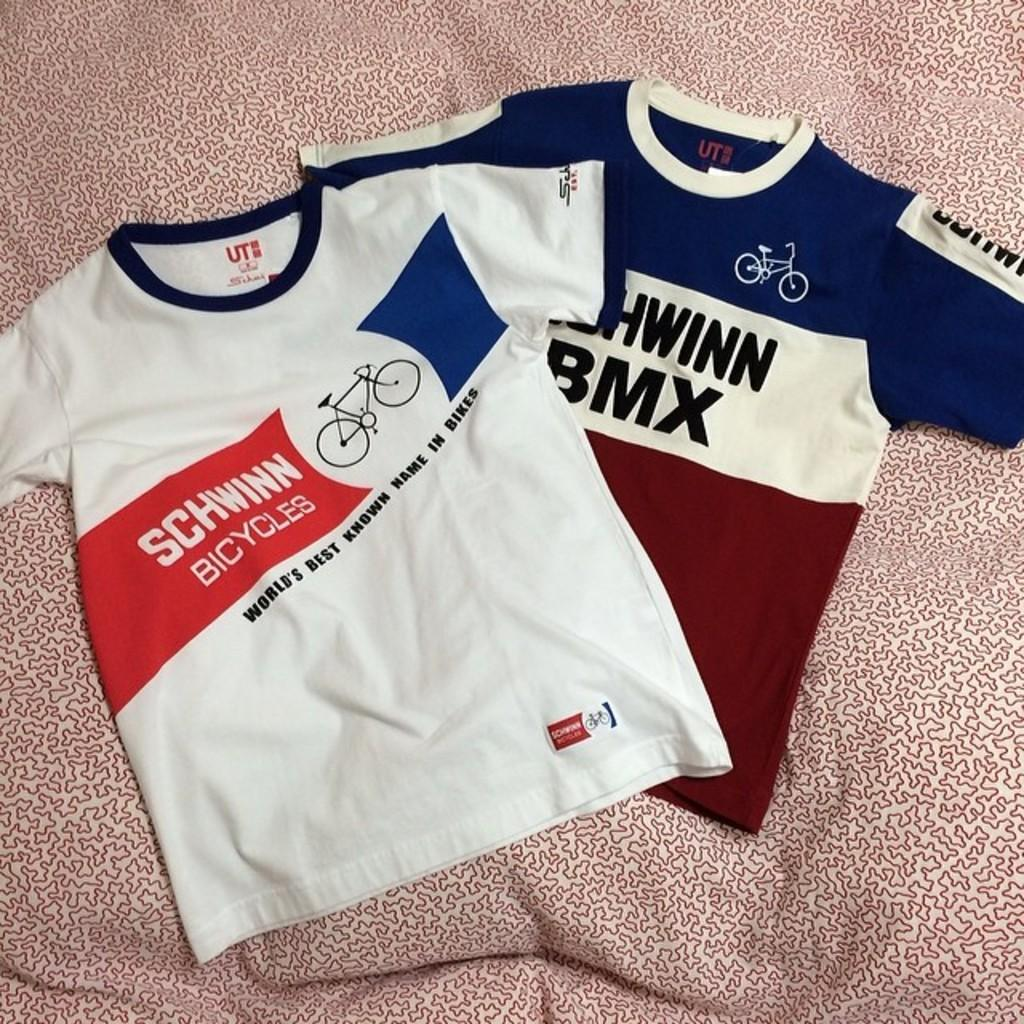<image>
Relay a brief, clear account of the picture shown. Two cycling tops lay side by side both carrying the logo Schwinn Bicycles 